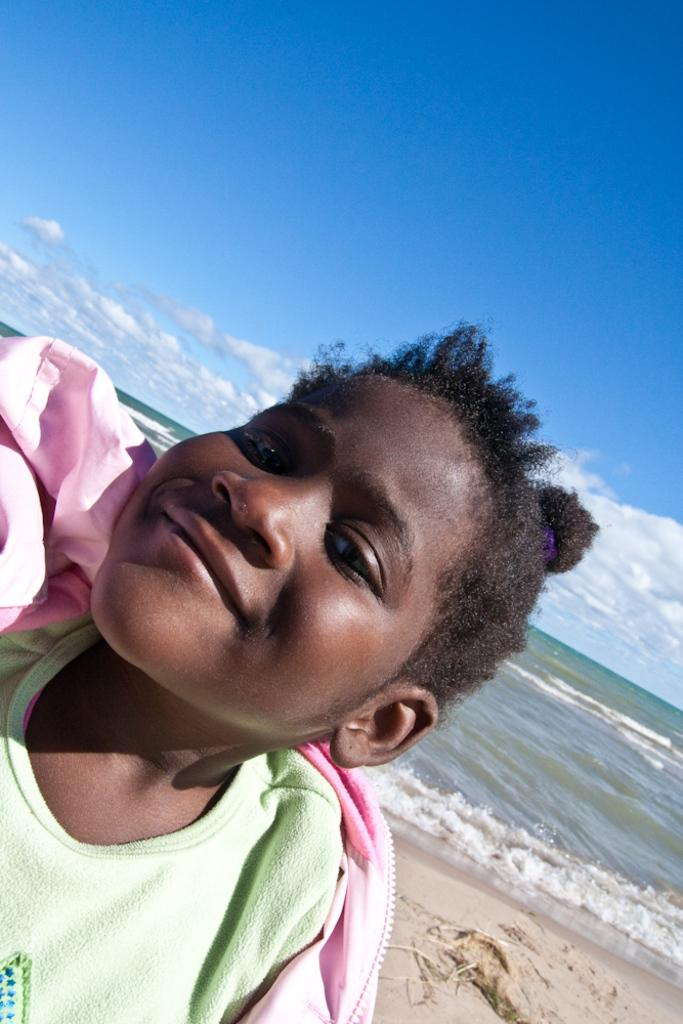What is the main subject of the picture? The main subject of the picture is a child. Where is the child standing in the image? The child is standing on the sand. What type of terrain is visible in the image? There is sand and water visible in the image. What is visible in the sky in the image? The sky is visible in the image, and clouds are present. What type of creature is the child trying to crush in the image? There is no creature present in the image for the child to crush. What is the child eating for dinner in the image? The image does not show the child eating dinner, so it cannot be determined from the picture. 